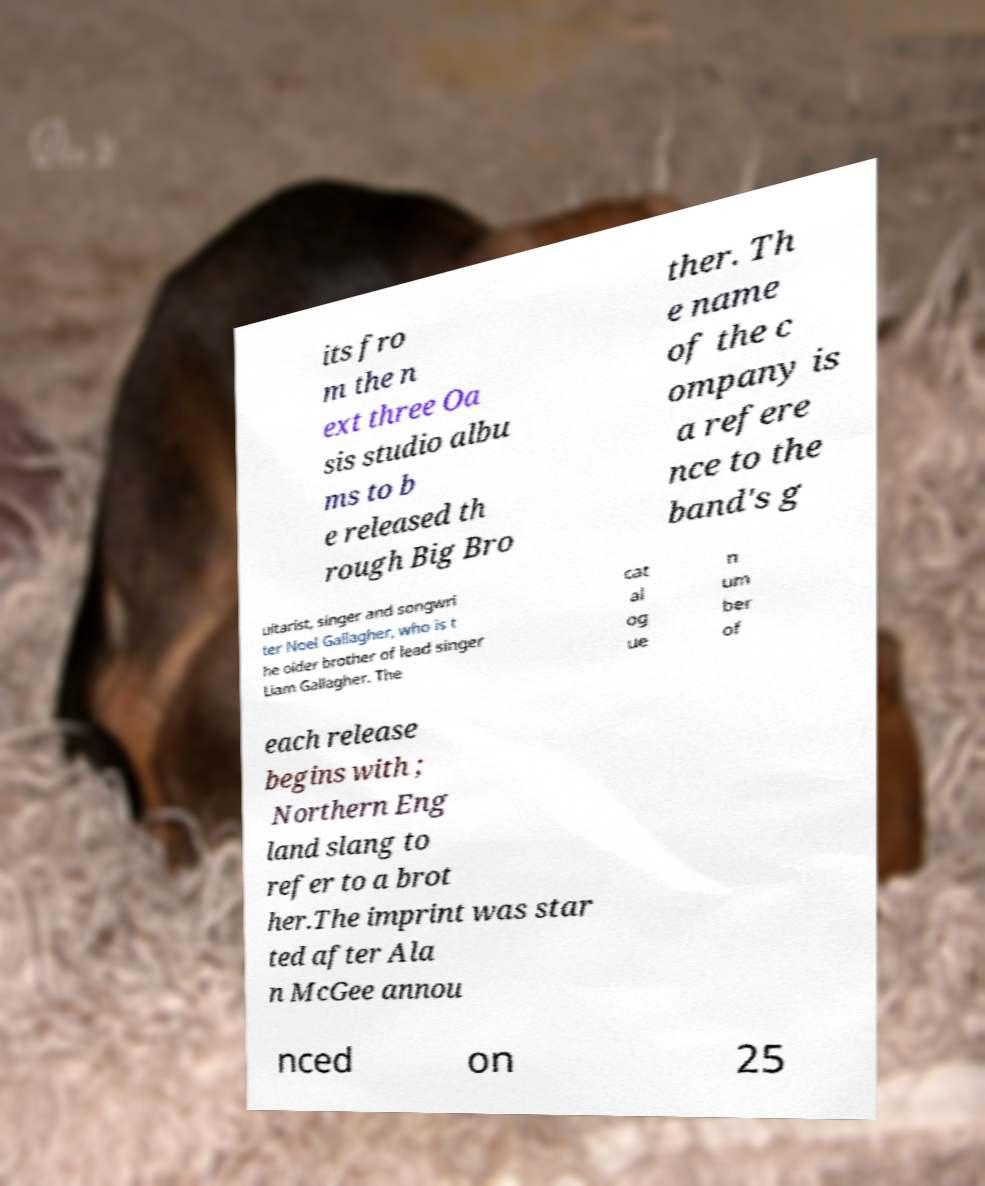Can you read and provide the text displayed in the image?This photo seems to have some interesting text. Can you extract and type it out for me? its fro m the n ext three Oa sis studio albu ms to b e released th rough Big Bro ther. Th e name of the c ompany is a refere nce to the band's g uitarist, singer and songwri ter Noel Gallagher, who is t he older brother of lead singer Liam Gallagher. The cat al og ue n um ber of each release begins with ; Northern Eng land slang to refer to a brot her.The imprint was star ted after Ala n McGee annou nced on 25 